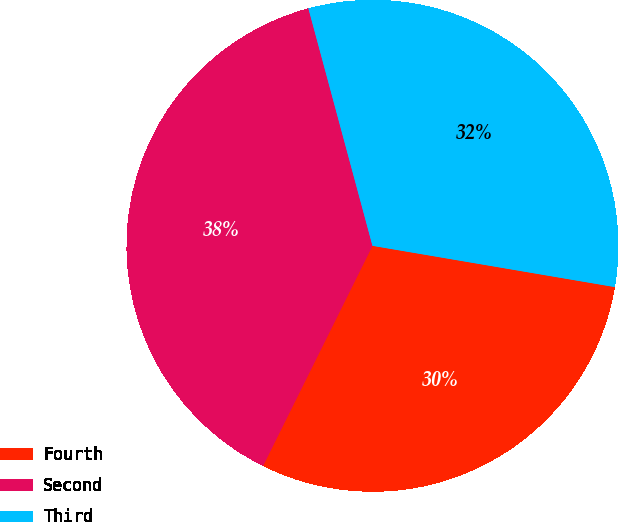Convert chart to OTSL. <chart><loc_0><loc_0><loc_500><loc_500><pie_chart><fcel>Fourth<fcel>Second<fcel>Third<nl><fcel>29.66%<fcel>38.46%<fcel>31.88%<nl></chart> 